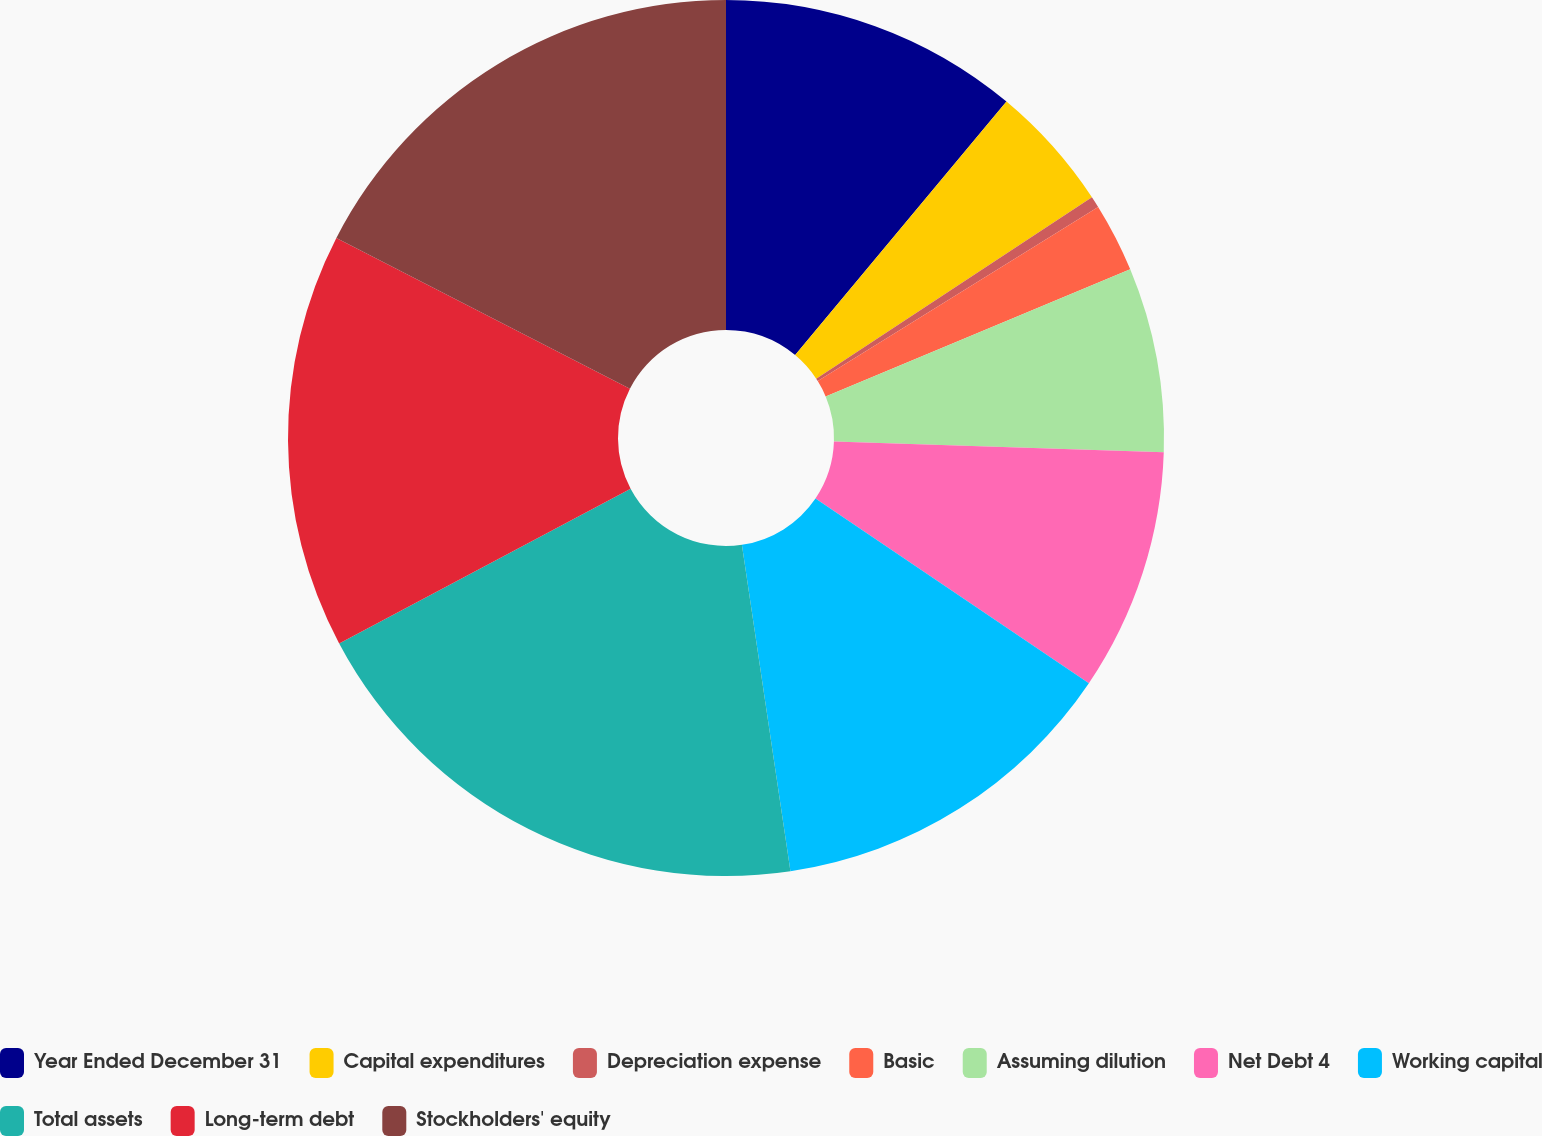Convert chart to OTSL. <chart><loc_0><loc_0><loc_500><loc_500><pie_chart><fcel>Year Ended December 31<fcel>Capital expenditures<fcel>Depreciation expense<fcel>Basic<fcel>Assuming dilution<fcel>Net Debt 4<fcel>Working capital<fcel>Total assets<fcel>Long-term debt<fcel>Stockholders' equity<nl><fcel>11.06%<fcel>4.68%<fcel>0.42%<fcel>2.55%<fcel>6.81%<fcel>8.94%<fcel>13.19%<fcel>19.58%<fcel>15.32%<fcel>17.45%<nl></chart> 